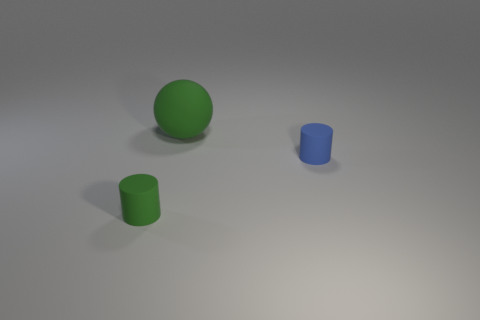How many large yellow matte things are there?
Make the answer very short. 0. What number of tiny matte objects have the same color as the big rubber object?
Offer a very short reply. 1. How big is the green sphere?
Keep it short and to the point. Large. Do the big green matte thing and the green matte object in front of the rubber ball have the same shape?
Ensure brevity in your answer.  No. What color is the big ball that is the same material as the green cylinder?
Ensure brevity in your answer.  Green. What size is the matte object behind the blue thing?
Keep it short and to the point. Large. Is the number of rubber cylinders that are in front of the blue object less than the number of large red metallic things?
Keep it short and to the point. No. Is there anything else that has the same shape as the blue rubber object?
Keep it short and to the point. Yes. Are there fewer purple cylinders than green cylinders?
Give a very brief answer. Yes. There is a small rubber thing that is on the left side of the matte cylinder that is behind the green rubber cylinder; what is its color?
Make the answer very short. Green. 